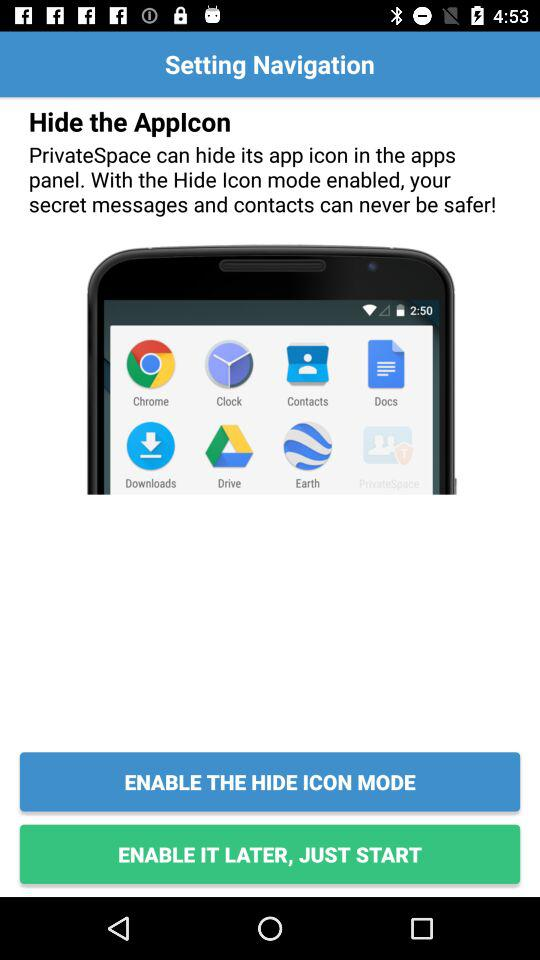Through which applications can we share content?
When the provided information is insufficient, respond with <no answer>. <no answer> 